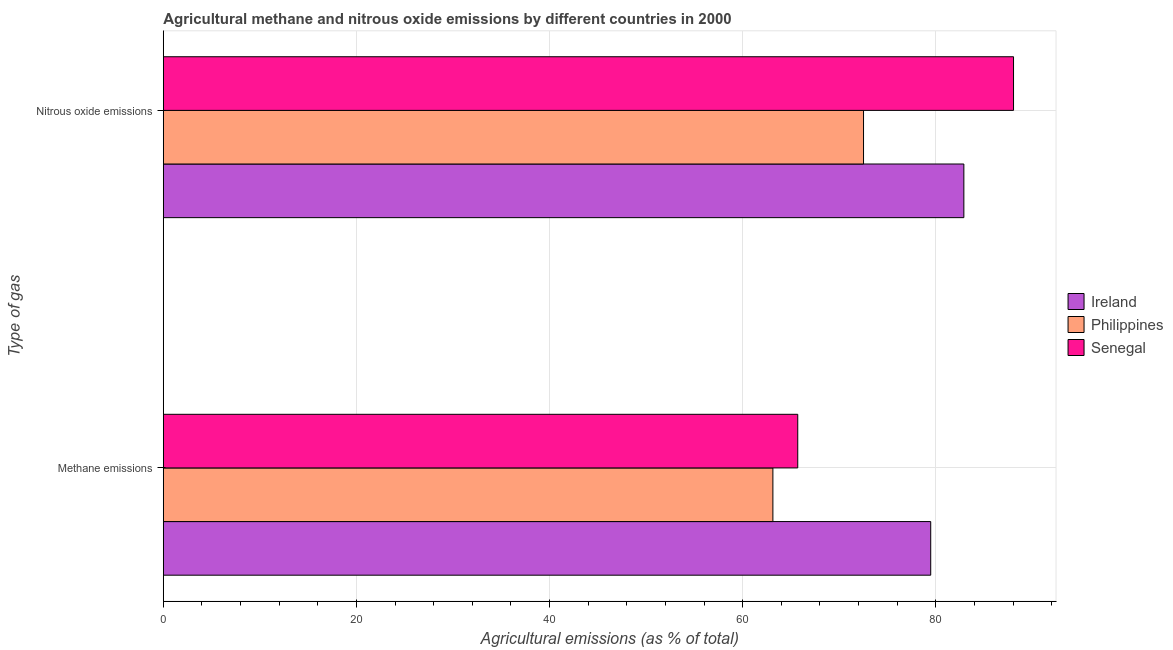How many groups of bars are there?
Keep it short and to the point. 2. Are the number of bars on each tick of the Y-axis equal?
Your response must be concise. Yes. How many bars are there on the 1st tick from the top?
Make the answer very short. 3. How many bars are there on the 2nd tick from the bottom?
Keep it short and to the point. 3. What is the label of the 1st group of bars from the top?
Your response must be concise. Nitrous oxide emissions. What is the amount of nitrous oxide emissions in Ireland?
Your answer should be compact. 82.91. Across all countries, what is the maximum amount of nitrous oxide emissions?
Give a very brief answer. 88.05. Across all countries, what is the minimum amount of nitrous oxide emissions?
Give a very brief answer. 72.52. In which country was the amount of nitrous oxide emissions maximum?
Ensure brevity in your answer.  Senegal. In which country was the amount of nitrous oxide emissions minimum?
Your answer should be very brief. Philippines. What is the total amount of nitrous oxide emissions in the graph?
Provide a short and direct response. 243.48. What is the difference between the amount of methane emissions in Philippines and that in Senegal?
Give a very brief answer. -2.57. What is the difference between the amount of methane emissions in Ireland and the amount of nitrous oxide emissions in Senegal?
Provide a short and direct response. -8.58. What is the average amount of methane emissions per country?
Give a very brief answer. 69.44. What is the difference between the amount of methane emissions and amount of nitrous oxide emissions in Philippines?
Ensure brevity in your answer.  -9.39. In how many countries, is the amount of methane emissions greater than 64 %?
Your answer should be compact. 2. What is the ratio of the amount of methane emissions in Senegal to that in Philippines?
Your answer should be compact. 1.04. Is the amount of nitrous oxide emissions in Ireland less than that in Philippines?
Ensure brevity in your answer.  No. In how many countries, is the amount of methane emissions greater than the average amount of methane emissions taken over all countries?
Offer a terse response. 1. What does the 1st bar from the top in Methane emissions represents?
Keep it short and to the point. Senegal. What does the 3rd bar from the bottom in Nitrous oxide emissions represents?
Give a very brief answer. Senegal. Where does the legend appear in the graph?
Make the answer very short. Center right. How are the legend labels stacked?
Provide a short and direct response. Vertical. What is the title of the graph?
Offer a terse response. Agricultural methane and nitrous oxide emissions by different countries in 2000. What is the label or title of the X-axis?
Offer a terse response. Agricultural emissions (as % of total). What is the label or title of the Y-axis?
Keep it short and to the point. Type of gas. What is the Agricultural emissions (as % of total) in Ireland in Methane emissions?
Ensure brevity in your answer.  79.48. What is the Agricultural emissions (as % of total) in Philippines in Methane emissions?
Provide a succinct answer. 63.13. What is the Agricultural emissions (as % of total) in Senegal in Methane emissions?
Offer a terse response. 65.71. What is the Agricultural emissions (as % of total) in Ireland in Nitrous oxide emissions?
Your response must be concise. 82.91. What is the Agricultural emissions (as % of total) of Philippines in Nitrous oxide emissions?
Your response must be concise. 72.52. What is the Agricultural emissions (as % of total) of Senegal in Nitrous oxide emissions?
Your answer should be compact. 88.05. Across all Type of gas, what is the maximum Agricultural emissions (as % of total) in Ireland?
Keep it short and to the point. 82.91. Across all Type of gas, what is the maximum Agricultural emissions (as % of total) of Philippines?
Give a very brief answer. 72.52. Across all Type of gas, what is the maximum Agricultural emissions (as % of total) in Senegal?
Make the answer very short. 88.05. Across all Type of gas, what is the minimum Agricultural emissions (as % of total) of Ireland?
Your response must be concise. 79.48. Across all Type of gas, what is the minimum Agricultural emissions (as % of total) of Philippines?
Your answer should be compact. 63.13. Across all Type of gas, what is the minimum Agricultural emissions (as % of total) in Senegal?
Provide a succinct answer. 65.71. What is the total Agricultural emissions (as % of total) in Ireland in the graph?
Make the answer very short. 162.38. What is the total Agricultural emissions (as % of total) of Philippines in the graph?
Offer a terse response. 135.65. What is the total Agricultural emissions (as % of total) of Senegal in the graph?
Ensure brevity in your answer.  153.76. What is the difference between the Agricultural emissions (as % of total) in Ireland in Methane emissions and that in Nitrous oxide emissions?
Your response must be concise. -3.43. What is the difference between the Agricultural emissions (as % of total) of Philippines in Methane emissions and that in Nitrous oxide emissions?
Give a very brief answer. -9.39. What is the difference between the Agricultural emissions (as % of total) of Senegal in Methane emissions and that in Nitrous oxide emissions?
Ensure brevity in your answer.  -22.35. What is the difference between the Agricultural emissions (as % of total) of Ireland in Methane emissions and the Agricultural emissions (as % of total) of Philippines in Nitrous oxide emissions?
Your response must be concise. 6.96. What is the difference between the Agricultural emissions (as % of total) of Ireland in Methane emissions and the Agricultural emissions (as % of total) of Senegal in Nitrous oxide emissions?
Your answer should be compact. -8.58. What is the difference between the Agricultural emissions (as % of total) of Philippines in Methane emissions and the Agricultural emissions (as % of total) of Senegal in Nitrous oxide emissions?
Your answer should be very brief. -24.92. What is the average Agricultural emissions (as % of total) of Ireland per Type of gas?
Your answer should be very brief. 81.19. What is the average Agricultural emissions (as % of total) of Philippines per Type of gas?
Provide a succinct answer. 67.82. What is the average Agricultural emissions (as % of total) of Senegal per Type of gas?
Ensure brevity in your answer.  76.88. What is the difference between the Agricultural emissions (as % of total) of Ireland and Agricultural emissions (as % of total) of Philippines in Methane emissions?
Your response must be concise. 16.35. What is the difference between the Agricultural emissions (as % of total) of Ireland and Agricultural emissions (as % of total) of Senegal in Methane emissions?
Make the answer very short. 13.77. What is the difference between the Agricultural emissions (as % of total) of Philippines and Agricultural emissions (as % of total) of Senegal in Methane emissions?
Offer a terse response. -2.57. What is the difference between the Agricultural emissions (as % of total) in Ireland and Agricultural emissions (as % of total) in Philippines in Nitrous oxide emissions?
Keep it short and to the point. 10.39. What is the difference between the Agricultural emissions (as % of total) in Ireland and Agricultural emissions (as % of total) in Senegal in Nitrous oxide emissions?
Offer a terse response. -5.14. What is the difference between the Agricultural emissions (as % of total) in Philippines and Agricultural emissions (as % of total) in Senegal in Nitrous oxide emissions?
Ensure brevity in your answer.  -15.53. What is the ratio of the Agricultural emissions (as % of total) in Ireland in Methane emissions to that in Nitrous oxide emissions?
Offer a terse response. 0.96. What is the ratio of the Agricultural emissions (as % of total) of Philippines in Methane emissions to that in Nitrous oxide emissions?
Your response must be concise. 0.87. What is the ratio of the Agricultural emissions (as % of total) in Senegal in Methane emissions to that in Nitrous oxide emissions?
Provide a succinct answer. 0.75. What is the difference between the highest and the second highest Agricultural emissions (as % of total) of Ireland?
Provide a succinct answer. 3.43. What is the difference between the highest and the second highest Agricultural emissions (as % of total) in Philippines?
Offer a very short reply. 9.39. What is the difference between the highest and the second highest Agricultural emissions (as % of total) in Senegal?
Provide a short and direct response. 22.35. What is the difference between the highest and the lowest Agricultural emissions (as % of total) in Ireland?
Provide a succinct answer. 3.43. What is the difference between the highest and the lowest Agricultural emissions (as % of total) in Philippines?
Offer a very short reply. 9.39. What is the difference between the highest and the lowest Agricultural emissions (as % of total) of Senegal?
Provide a short and direct response. 22.35. 